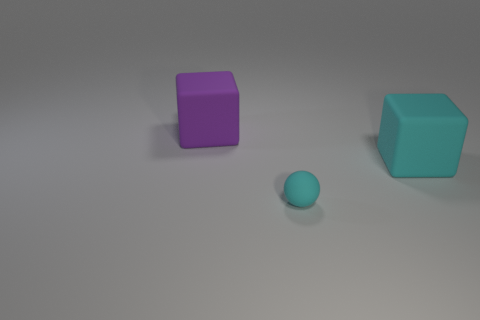There is a cyan matte thing on the left side of the cyan block behind the tiny rubber sphere; what number of big purple matte cubes are on the left side of it?
Your answer should be compact. 1. What is the color of the large matte thing that is left of the tiny cyan ball?
Ensure brevity in your answer.  Purple. There is a cyan rubber thing in front of the big object right of the large purple matte block; what shape is it?
Provide a succinct answer. Sphere. How many blocks are small objects or large purple matte objects?
Ensure brevity in your answer.  1. There is a thing that is behind the tiny cyan ball and on the left side of the cyan rubber cube; what material is it?
Give a very brief answer. Rubber. There is a cyan rubber block; what number of cyan things are on the left side of it?
Give a very brief answer. 1. Is the block to the left of the small cyan matte thing made of the same material as the large block to the right of the rubber sphere?
Your answer should be very brief. Yes. How many objects are either matte cubes that are in front of the big purple matte thing or small balls?
Your answer should be compact. 2. Are there fewer purple matte things that are in front of the purple matte block than matte objects that are on the left side of the big cyan object?
Provide a succinct answer. Yes. How many other objects are there of the same size as the purple object?
Your answer should be compact. 1. 